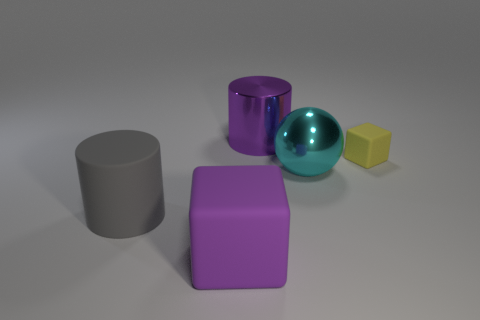The large ball is what color?
Keep it short and to the point. Cyan. Is there a thing that has the same color as the large matte cube?
Ensure brevity in your answer.  Yes. What shape is the large shiny object right of the big purple thing behind the purple object in front of the yellow rubber thing?
Your answer should be compact. Sphere. There is a block in front of the tiny yellow block; what material is it?
Your response must be concise. Rubber. What is the size of the rubber block to the right of the rubber cube that is in front of the metallic object that is in front of the tiny yellow rubber block?
Your answer should be very brief. Small. Do the gray matte object and the shiny thing right of the purple metal object have the same size?
Provide a short and direct response. Yes. There is a large cylinder that is on the right side of the purple rubber cube; what is its color?
Make the answer very short. Purple. The big object that is the same color as the big matte block is what shape?
Make the answer very short. Cylinder. What shape is the large metallic object on the left side of the cyan ball?
Your answer should be very brief. Cylinder. What number of blue things are either large blocks or rubber cubes?
Ensure brevity in your answer.  0. 